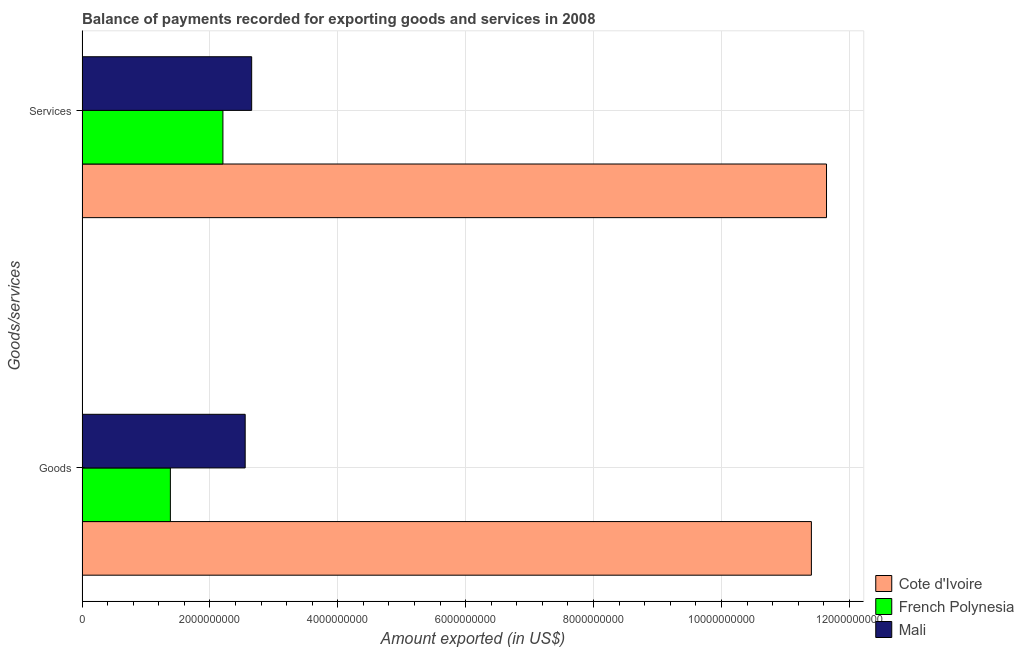How many groups of bars are there?
Offer a very short reply. 2. Are the number of bars per tick equal to the number of legend labels?
Ensure brevity in your answer.  Yes. How many bars are there on the 2nd tick from the bottom?
Give a very brief answer. 3. What is the label of the 1st group of bars from the top?
Provide a succinct answer. Services. What is the amount of services exported in Mali?
Offer a very short reply. 2.65e+09. Across all countries, what is the maximum amount of goods exported?
Provide a succinct answer. 1.14e+1. Across all countries, what is the minimum amount of goods exported?
Offer a terse response. 1.38e+09. In which country was the amount of goods exported maximum?
Offer a very short reply. Cote d'Ivoire. In which country was the amount of goods exported minimum?
Provide a short and direct response. French Polynesia. What is the total amount of goods exported in the graph?
Ensure brevity in your answer.  1.53e+1. What is the difference between the amount of goods exported in Cote d'Ivoire and that in French Polynesia?
Give a very brief answer. 1.00e+1. What is the difference between the amount of goods exported in French Polynesia and the amount of services exported in Cote d'Ivoire?
Your answer should be compact. -1.03e+1. What is the average amount of goods exported per country?
Your answer should be compact. 5.11e+09. What is the difference between the amount of services exported and amount of goods exported in Mali?
Offer a terse response. 1.02e+08. In how many countries, is the amount of goods exported greater than 7200000000 US$?
Your answer should be compact. 1. What is the ratio of the amount of services exported in Mali to that in French Polynesia?
Your answer should be compact. 1.2. Is the amount of goods exported in French Polynesia less than that in Mali?
Keep it short and to the point. Yes. What does the 1st bar from the top in Services represents?
Offer a very short reply. Mali. What does the 3rd bar from the bottom in Services represents?
Provide a short and direct response. Mali. How many countries are there in the graph?
Offer a terse response. 3. Are the values on the major ticks of X-axis written in scientific E-notation?
Your response must be concise. No. Where does the legend appear in the graph?
Provide a succinct answer. Bottom right. How many legend labels are there?
Your response must be concise. 3. How are the legend labels stacked?
Ensure brevity in your answer.  Vertical. What is the title of the graph?
Ensure brevity in your answer.  Balance of payments recorded for exporting goods and services in 2008. Does "Low & middle income" appear as one of the legend labels in the graph?
Your answer should be very brief. No. What is the label or title of the X-axis?
Provide a succinct answer. Amount exported (in US$). What is the label or title of the Y-axis?
Provide a succinct answer. Goods/services. What is the Amount exported (in US$) in Cote d'Ivoire in Goods?
Your response must be concise. 1.14e+1. What is the Amount exported (in US$) of French Polynesia in Goods?
Ensure brevity in your answer.  1.38e+09. What is the Amount exported (in US$) in Mali in Goods?
Keep it short and to the point. 2.55e+09. What is the Amount exported (in US$) of Cote d'Ivoire in Services?
Offer a terse response. 1.16e+1. What is the Amount exported (in US$) in French Polynesia in Services?
Your answer should be compact. 2.20e+09. What is the Amount exported (in US$) of Mali in Services?
Provide a short and direct response. 2.65e+09. Across all Goods/services, what is the maximum Amount exported (in US$) of Cote d'Ivoire?
Your response must be concise. 1.16e+1. Across all Goods/services, what is the maximum Amount exported (in US$) of French Polynesia?
Give a very brief answer. 2.20e+09. Across all Goods/services, what is the maximum Amount exported (in US$) in Mali?
Your response must be concise. 2.65e+09. Across all Goods/services, what is the minimum Amount exported (in US$) in Cote d'Ivoire?
Keep it short and to the point. 1.14e+1. Across all Goods/services, what is the minimum Amount exported (in US$) of French Polynesia?
Offer a terse response. 1.38e+09. Across all Goods/services, what is the minimum Amount exported (in US$) in Mali?
Provide a short and direct response. 2.55e+09. What is the total Amount exported (in US$) of Cote d'Ivoire in the graph?
Your answer should be compact. 2.30e+1. What is the total Amount exported (in US$) of French Polynesia in the graph?
Your response must be concise. 3.58e+09. What is the total Amount exported (in US$) in Mali in the graph?
Your answer should be very brief. 5.20e+09. What is the difference between the Amount exported (in US$) of Cote d'Ivoire in Goods and that in Services?
Your answer should be compact. -2.37e+08. What is the difference between the Amount exported (in US$) in French Polynesia in Goods and that in Services?
Offer a terse response. -8.22e+08. What is the difference between the Amount exported (in US$) of Mali in Goods and that in Services?
Your answer should be compact. -1.02e+08. What is the difference between the Amount exported (in US$) in Cote d'Ivoire in Goods and the Amount exported (in US$) in French Polynesia in Services?
Give a very brief answer. 9.20e+09. What is the difference between the Amount exported (in US$) in Cote d'Ivoire in Goods and the Amount exported (in US$) in Mali in Services?
Offer a very short reply. 8.75e+09. What is the difference between the Amount exported (in US$) of French Polynesia in Goods and the Amount exported (in US$) of Mali in Services?
Keep it short and to the point. -1.27e+09. What is the average Amount exported (in US$) in Cote d'Ivoire per Goods/services?
Your answer should be very brief. 1.15e+1. What is the average Amount exported (in US$) of French Polynesia per Goods/services?
Ensure brevity in your answer.  1.79e+09. What is the average Amount exported (in US$) of Mali per Goods/services?
Ensure brevity in your answer.  2.60e+09. What is the difference between the Amount exported (in US$) in Cote d'Ivoire and Amount exported (in US$) in French Polynesia in Goods?
Your answer should be very brief. 1.00e+1. What is the difference between the Amount exported (in US$) of Cote d'Ivoire and Amount exported (in US$) of Mali in Goods?
Provide a short and direct response. 8.86e+09. What is the difference between the Amount exported (in US$) of French Polynesia and Amount exported (in US$) of Mali in Goods?
Provide a short and direct response. -1.17e+09. What is the difference between the Amount exported (in US$) of Cote d'Ivoire and Amount exported (in US$) of French Polynesia in Services?
Your response must be concise. 9.44e+09. What is the difference between the Amount exported (in US$) of Cote d'Ivoire and Amount exported (in US$) of Mali in Services?
Offer a terse response. 8.99e+09. What is the difference between the Amount exported (in US$) of French Polynesia and Amount exported (in US$) of Mali in Services?
Ensure brevity in your answer.  -4.50e+08. What is the ratio of the Amount exported (in US$) in Cote d'Ivoire in Goods to that in Services?
Provide a succinct answer. 0.98. What is the ratio of the Amount exported (in US$) in French Polynesia in Goods to that in Services?
Make the answer very short. 0.63. What is the ratio of the Amount exported (in US$) in Mali in Goods to that in Services?
Keep it short and to the point. 0.96. What is the difference between the highest and the second highest Amount exported (in US$) of Cote d'Ivoire?
Give a very brief answer. 2.37e+08. What is the difference between the highest and the second highest Amount exported (in US$) of French Polynesia?
Make the answer very short. 8.22e+08. What is the difference between the highest and the second highest Amount exported (in US$) of Mali?
Provide a short and direct response. 1.02e+08. What is the difference between the highest and the lowest Amount exported (in US$) of Cote d'Ivoire?
Offer a very short reply. 2.37e+08. What is the difference between the highest and the lowest Amount exported (in US$) in French Polynesia?
Keep it short and to the point. 8.22e+08. What is the difference between the highest and the lowest Amount exported (in US$) in Mali?
Provide a succinct answer. 1.02e+08. 